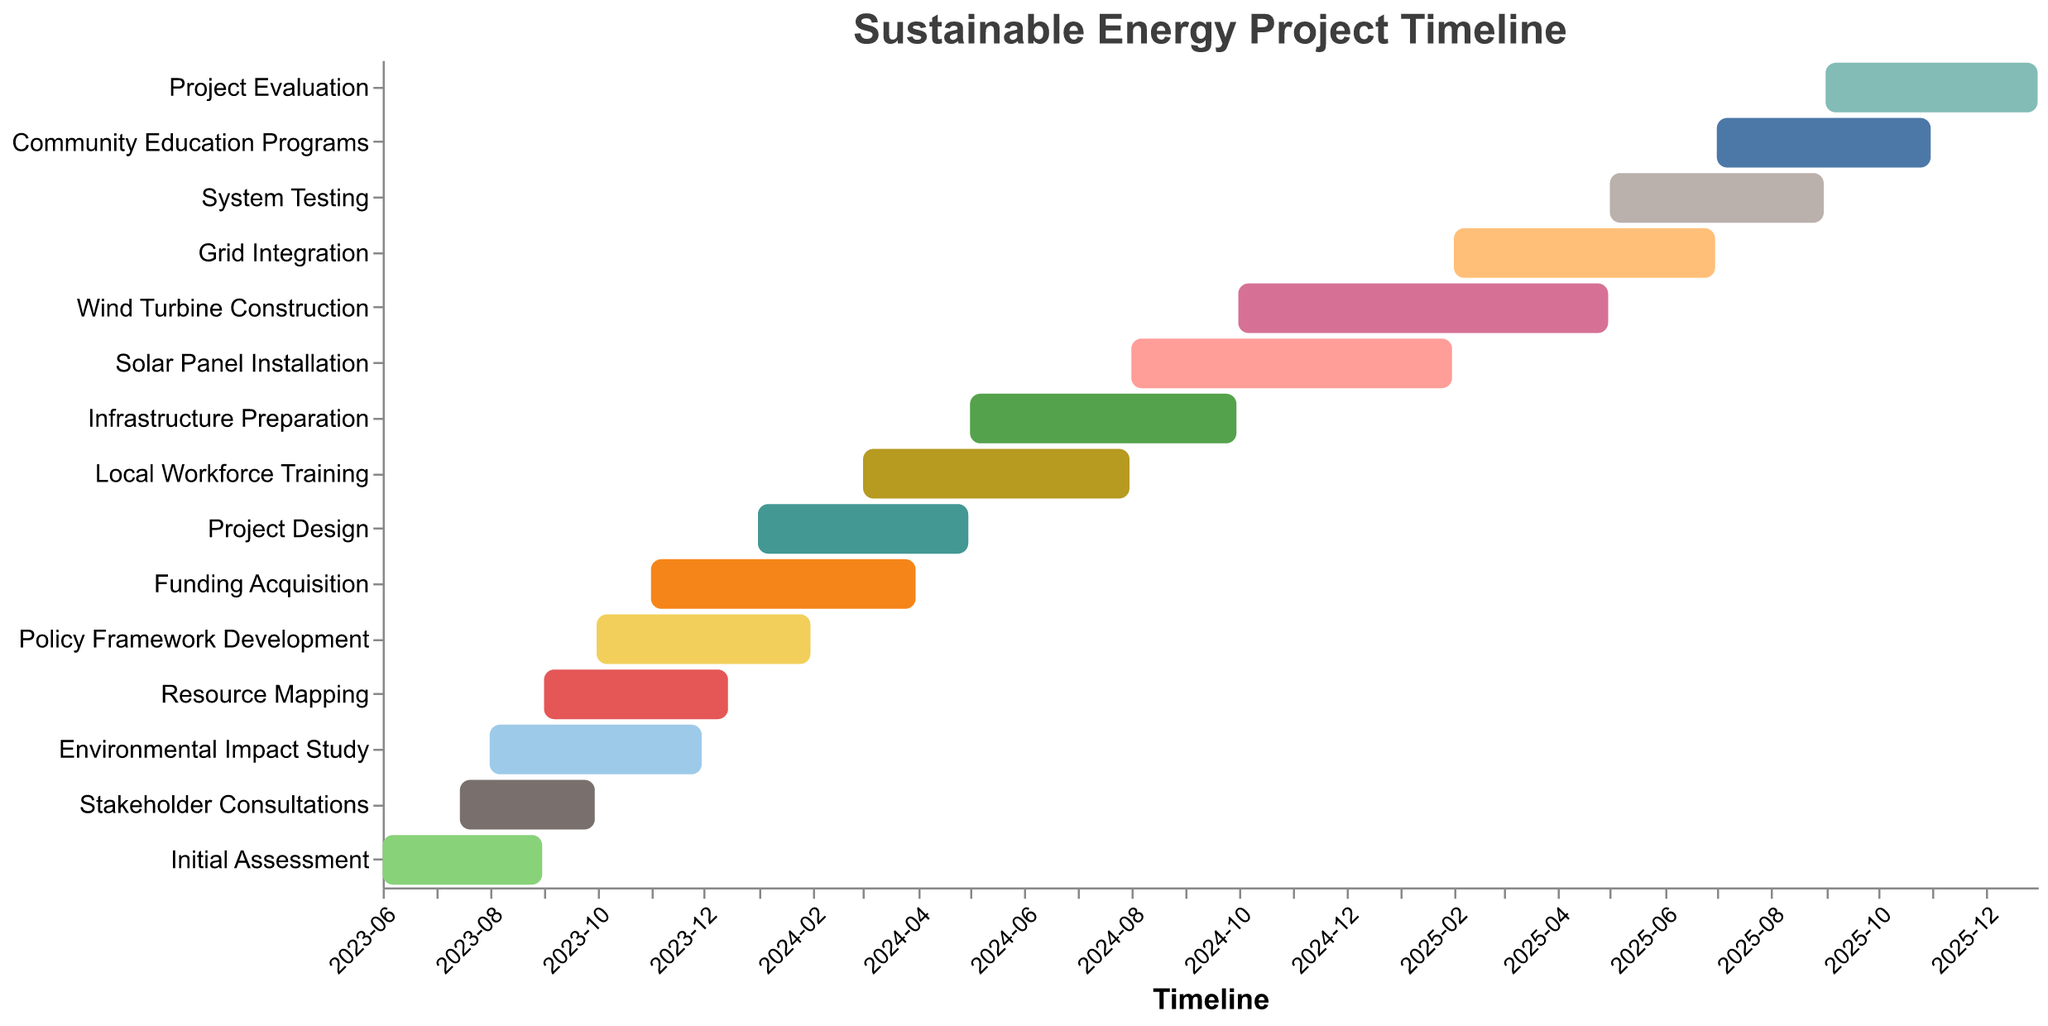What is the title of the figure? The title of the figure is located at the top and reads "Sustainable Energy Project Timeline."
Answer: Sustainable Energy Project Timeline What are the start and end dates for the Initial Assessment phase? The Initial Assessment phase has a start date of "2023-06-01" and an end date of "2023-08-31," as indicated by the bar for that task on the chart.
Answer: 2023-06-01 to 2023-08-31 Which task runs the longest in the timeline, and what is its duration? The Wind Turbine Construction task runs from "2024-10-01" to "2025-04-30," a total of about 7 months, making it the longest task on the timeline.
Answer: Wind Turbine Construction, 7 months Which tasks overlap with the Stakeholder Consultations phase? The Stakeholder Consultations phase overlaps with the Initial Assessment (June to Aug 2023), Environmental Impact Study (Aug to Nov 2023), and Resource Mapping (Sept to Dec 2023).
Answer: Initial Assessment, Environmental Impact Study, Resource Mapping How many tasks start in the year 2024? By examining the start dates, six tasks begin in 2024: Policy Framework Development, Project Design, Local Workforce Training, Infrastructure Preparation, Solar Panel Installation, and Wind Turbine Construction.
Answer: Six tasks What tasks are assigned for system-related activities and when do they occur? System-related tasks such as Grid Integration and System Testing occur from Feb 2025 to June 2025 and May 2025 to Aug 2025, respectively.
Answer: Grid Integration (Feb-Jun 2025), System Testing (May-Aug 2025) When does the Funding Acquisition phase end, and what task follows it? The Funding Acquisition phase ends on "2024-03-31," and the Project Design phase begins immediately after on "2024-04-01."
Answer: 2024-03-31, Project Design Which tasks take place during the year 2025? Tasks in 2025 include Grid Integration (Feb - Jun), System Testing (May - Aug), Community Education Programs (Jul - Oct), and Project Evaluation (Sep - Dec).
Answer: Grid Integration, System Testing, Community Education Programs, Project Evaluation What is the overall duration of the project from the first to the last task? The project starts with the Initial Assessment on "2023-06-01" and finishes with the Project Evaluation on "2025-12-31." Thus, it spans about 2.5 years.
Answer: 2.5 years 